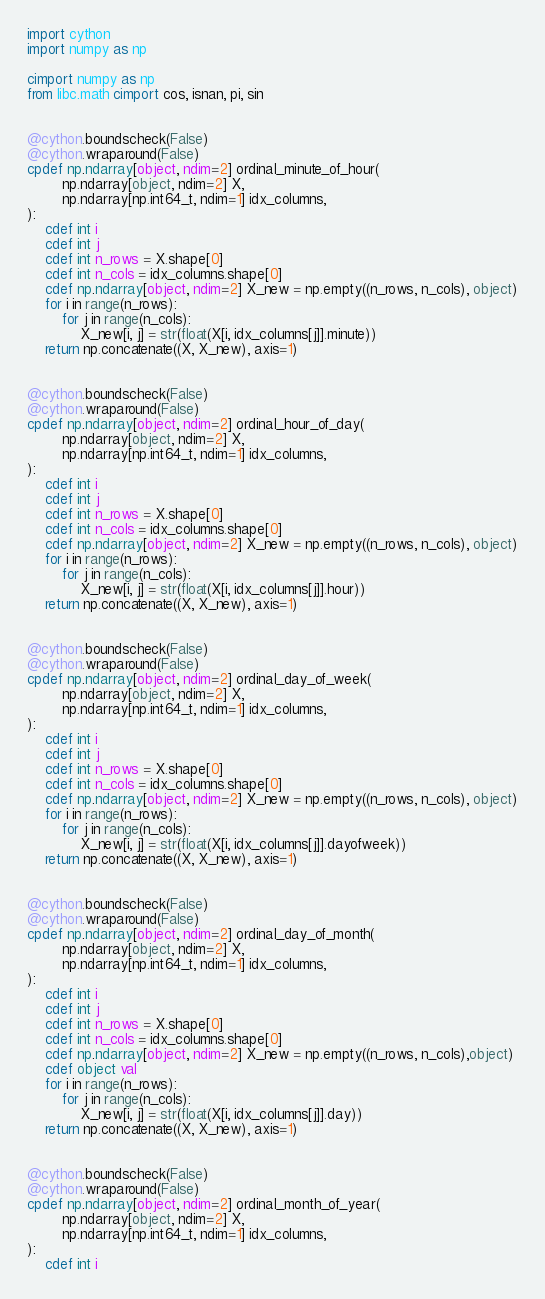Convert code to text. <code><loc_0><loc_0><loc_500><loc_500><_Cython_>import cython
import numpy as np

cimport numpy as np
from libc.math cimport cos, isnan, pi, sin


@cython.boundscheck(False)
@cython.wraparound(False)
cpdef np.ndarray[object, ndim=2] ordinal_minute_of_hour(
        np.ndarray[object, ndim=2] X,
        np.ndarray[np.int64_t, ndim=1] idx_columns,
):
    cdef int i
    cdef int j
    cdef int n_rows = X.shape[0]
    cdef int n_cols = idx_columns.shape[0]
    cdef np.ndarray[object, ndim=2] X_new = np.empty((n_rows, n_cols), object)
    for i in range(n_rows):
        for j in range(n_cols):
            X_new[i, j] = str(float(X[i, idx_columns[j]].minute))
    return np.concatenate((X, X_new), axis=1)


@cython.boundscheck(False)
@cython.wraparound(False)
cpdef np.ndarray[object, ndim=2] ordinal_hour_of_day(
        np.ndarray[object, ndim=2] X,
        np.ndarray[np.int64_t, ndim=1] idx_columns,
):
    cdef int i
    cdef int j
    cdef int n_rows = X.shape[0]
    cdef int n_cols = idx_columns.shape[0]
    cdef np.ndarray[object, ndim=2] X_new = np.empty((n_rows, n_cols), object)
    for i in range(n_rows):
        for j in range(n_cols):
            X_new[i, j] = str(float(X[i, idx_columns[j]].hour))
    return np.concatenate((X, X_new), axis=1)

   
@cython.boundscheck(False)
@cython.wraparound(False)
cpdef np.ndarray[object, ndim=2] ordinal_day_of_week(
        np.ndarray[object, ndim=2] X,
        np.ndarray[np.int64_t, ndim=1] idx_columns,
):
    cdef int i
    cdef int j
    cdef int n_rows = X.shape[0]
    cdef int n_cols = idx_columns.shape[0]
    cdef np.ndarray[object, ndim=2] X_new = np.empty((n_rows, n_cols), object)
    for i in range(n_rows):
        for j in range(n_cols):
            X_new[i, j] = str(float(X[i, idx_columns[j]].dayofweek))
    return np.concatenate((X, X_new), axis=1)


@cython.boundscheck(False)
@cython.wraparound(False)
cpdef np.ndarray[object, ndim=2] ordinal_day_of_month(
        np.ndarray[object, ndim=2] X,
        np.ndarray[np.int64_t, ndim=1] idx_columns,
):
    cdef int i
    cdef int j
    cdef int n_rows = X.shape[0]
    cdef int n_cols = idx_columns.shape[0]
    cdef np.ndarray[object, ndim=2] X_new = np.empty((n_rows, n_cols),object)
    cdef object val
    for i in range(n_rows):
        for j in range(n_cols):
            X_new[i, j] = str(float(X[i, idx_columns[j]].day))
    return np.concatenate((X, X_new), axis=1)


@cython.boundscheck(False)
@cython.wraparound(False)
cpdef np.ndarray[object, ndim=2] ordinal_month_of_year(
        np.ndarray[object, ndim=2] X,
        np.ndarray[np.int64_t, ndim=1] idx_columns,
):
    cdef int i</code> 